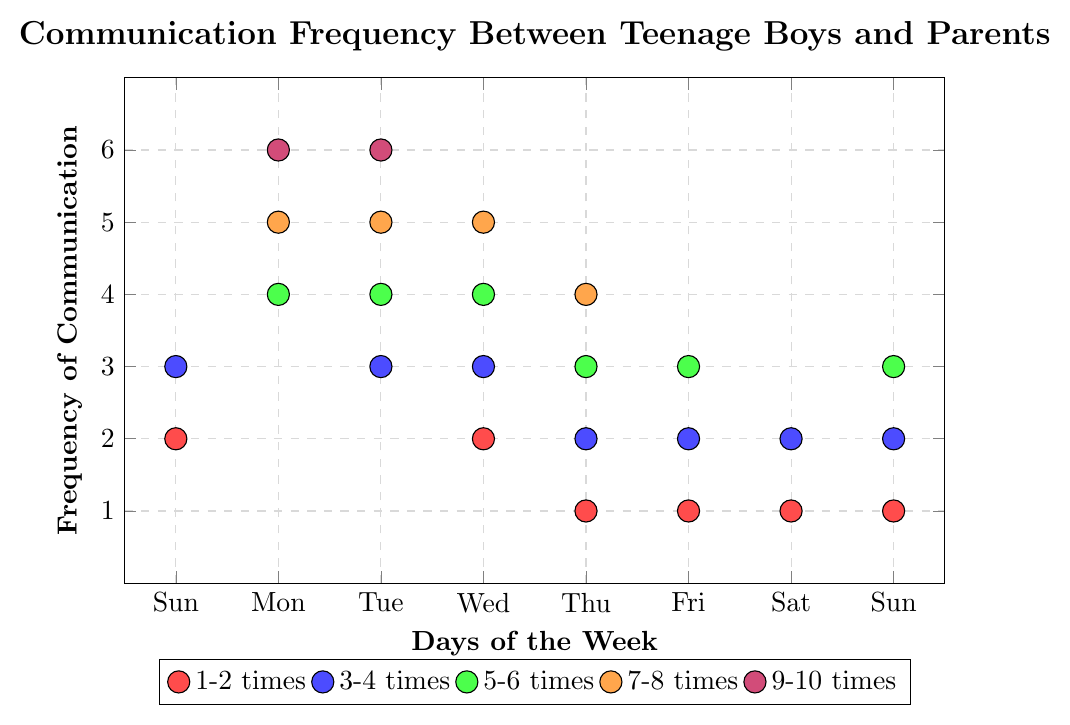What's the most frequent communication frequency on Monday? Look at the data points for Monday (1) on the x-axis. The y-values (frequencies) are 4, 5, and 6. Therefore, the most frequent communication frequency on Monday is the highest value among them, which is 6.
Answer: 6 Which day has the least communication frequency recorded, and what is it? Observe the y-values for each day. The lowest frequency recorded is 1, which can be seen on Thursday (4), Friday (5), Saturday (6), and Sunday (7). Therefore, Thursday is one of the days with the least communication frequency recorded, which is 1.
Answer: Thursday, 1 What is the average frequency of communication on Sundays? Find the data points for Sunday (0) and (7). The frequencies are 2, 3 for day 0 and 1, 2, 3 for day 7. Sum these frequencies up (2 + 3 + 1 + 2 + 3 = 11) and divide by the number of data points (5). The average is 11/5 = 2.2.
Answer: 2.2 How many times do the frequencies 3 and 4 appear in total throughout the week? Locate all instances of frequencies 3 and 4 across all days. Count each occurrence: frequency 3 appears 7 times (Sunday:1, Wednesday:1, Thursday:1, Friday:1, Saturday:1, second Sunday:2) and frequency 4 appears 5 times (Monday:1, Tuesday:1, Wednesday:1, Thursday:1). Therefore, the total count is 7 + 5 = 12.
Answer: 12 On which days does the communication frequency reach 5 or higher? Identify the data points with frequencies 5 and above. For frequency 5: Monday (1), Tuesday (2), and Wednesday (3). For frequency 6: Tuesday (2) and Monday (1). Hence, the days are Monday, Tuesday, and Wednesday.
Answer: Monday, Tuesday, Wednesday Which color represents a communication frequency of 3? Look at the legend on the figure. The color representing `3-4 times` is blue. Since a frequency of 3 falls within this range, it is represented by the color blue.
Answer: Blue How does the frequency distribution on Wednesday compare with that on Tuesday? Examine the y-values (frequencies) for Tuesday (2) and Wednesday (3). For Tuesday: 3, 4, 5, 6. For Wednesday: 2, 3, 4, 5. Tuesday has higher frequencies overall, peaking at 6, while the highest for Wednesday is 5.
Answer: Tuesday has higher distribution If the frequency trend from the previous data points continued, what might be a reasonable prediction for Thursday’s upcoming frequency? Observing the pattern, there is a decrease on Thursday relative to previous days. Hence predicting typically one point lower, previous high is 4, predicting 3 is reasonable.
Answer: 3 